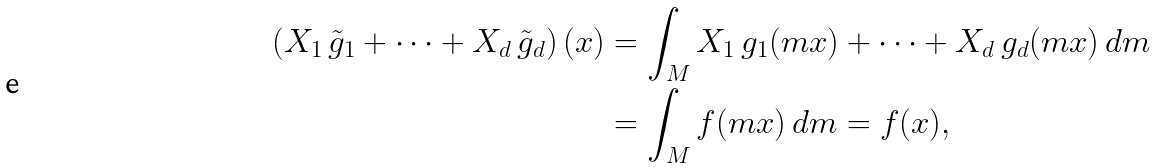<formula> <loc_0><loc_0><loc_500><loc_500>\left ( X _ { 1 } \, \tilde { g } _ { 1 } + \dots + X _ { d } \, \tilde { g } _ { d } \right ) ( x ) & = \int _ { M } X _ { 1 } \, g _ { 1 } ( m x ) + \dots + X _ { d } \, g _ { d } ( m x ) \, d m \\ & = \int _ { M } f ( m x ) \, d m = f ( x ) ,</formula> 